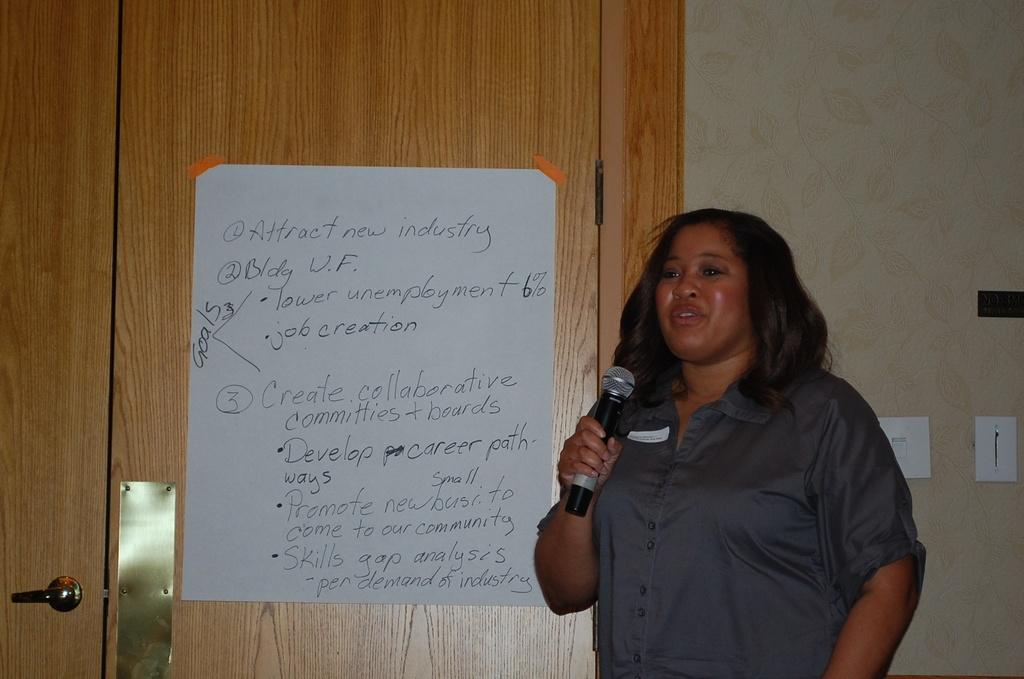What is on the door in the image? There is a poster on the door. What can be seen on the poster? There is something written on the poster. Who is in front of the wall in the image? A woman is standing in front of the wall. What is the woman holding? The woman is holding a mic. Is there a garden visible behind the woman in the image? No, there is no garden visible in the image. Can you tell me how the woman feels about her mother in the image? There is no information about the woman's feelings towards her mother in the image. 